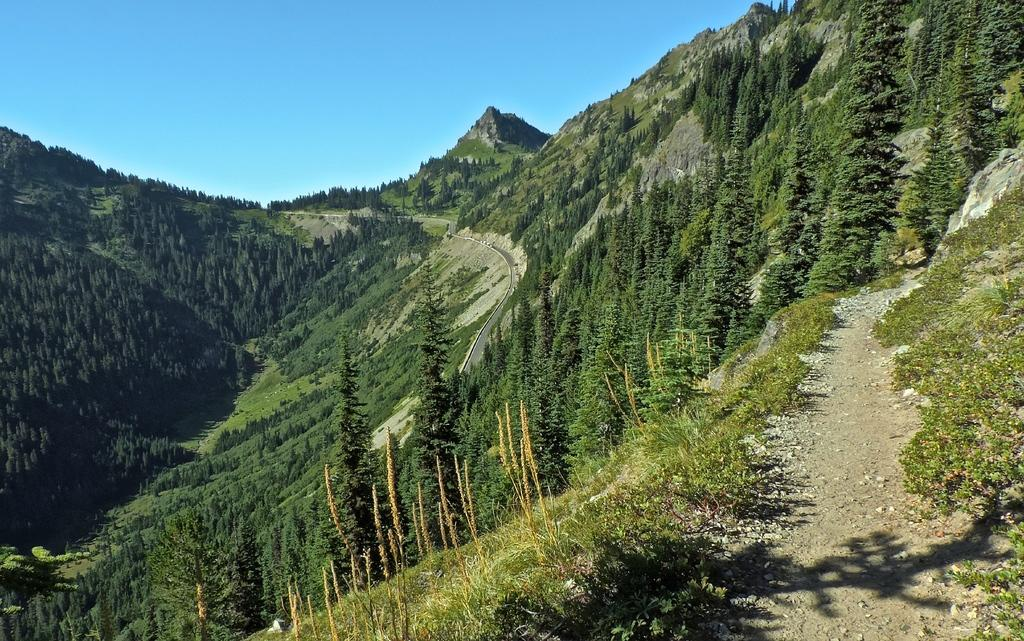What geographical features can be seen in the image? There are mountains in the image. What is covering the mountains in the image? The mountains are covered with trees. What type of tongue can be seen sticking out from the trees on the mountains in the image? There is no tongue present in the image; it features mountains covered with trees. How many dimes can be seen scattered on the mountains in the image? There are no dimes present in the image; it features mountains covered with trees. 